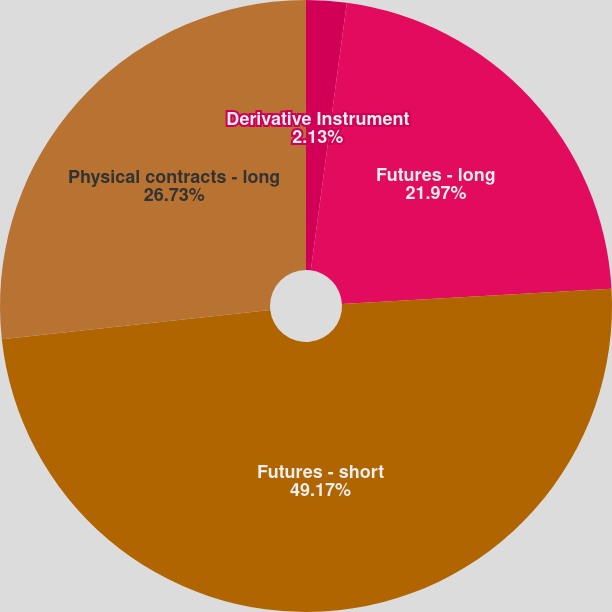Convert chart. <chart><loc_0><loc_0><loc_500><loc_500><pie_chart><fcel>Derivative Instrument<fcel>Futures - long<fcel>Futures - short<fcel>Physical contracts - long<nl><fcel>2.13%<fcel>21.97%<fcel>49.17%<fcel>26.73%<nl></chart> 